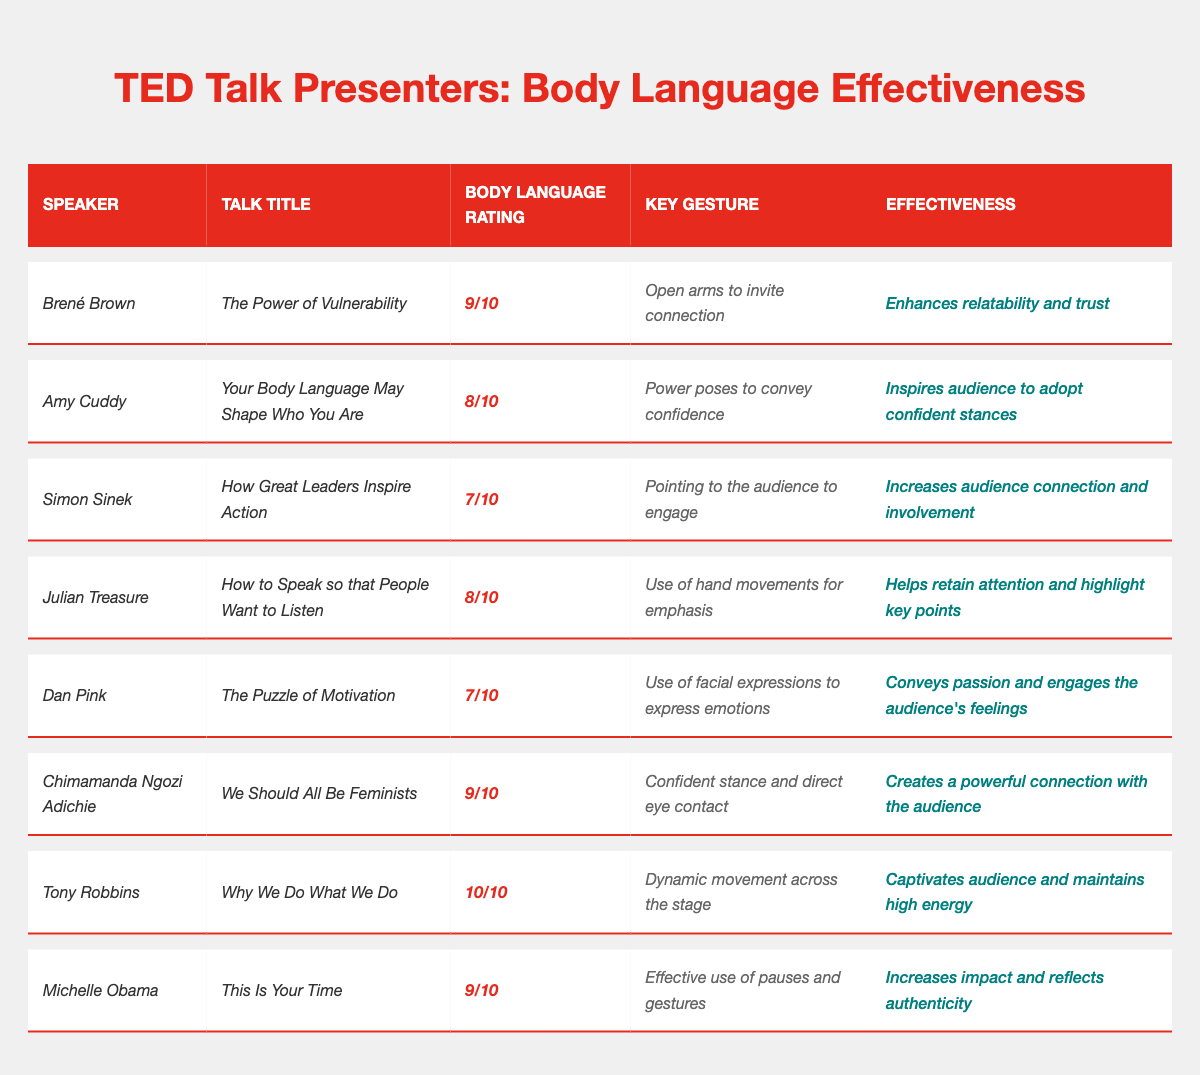What is the body language rating of Tony Robbins? The table shows that Tony Robbins has a body language rating of 10/10.
Answer: 10/10 Which speaker has the lowest body language rating? By checking the table, Simon Sinek and Dan Pink both have the lowest rating of 7/10.
Answer: Simon Sinek and Dan Pink What key gesture does Brené Brown use in her talk? The table indicates that Brené Brown's key gesture is "Open arms to invite connection."
Answer: Open arms to invite connection True or False: Michelle Obama has a higher body language rating than Simon Sinek. Comparing the ratings in the table, Michelle Obama (9/10) has a higher rating than Simon Sinek (7/10), so the statement is true.
Answer: True What is the effectiveness of Amy Cuddy's body language? The effectiveness of Amy Cuddy's body language, as noted in the table, is "Inspires audience to adopt confident stances."
Answer: Inspires audience to adopt confident stances Calculate the average body language rating of all presenters mentioned. The ratings are 9, 8, 7, 8, 7, 9, 10, and 9. Adding them gives 67. There are 8 ratings, so the average is 67/8 = 8.375.
Answer: 8.375 Which speaker uses a confident stance and direct eye contact as a key gesture? The table specifies that Chimamanda Ngozi Adichie uses a confident stance and direct eye contact.
Answer: Chimamanda Ngozi Adichie Who has the highest effectiveness rating and what is it? Tony Robbins has the highest effectiveness rating, which is "Captivates audience and maintains high energy."
Answer: Tony Robbins; Captivates audience and maintains high energy Is there any speaker who has a body language rating of 8/10? Yes, both Amy Cuddy and Julian Treasure have a body language rating of 8/10.
Answer: Yes What body language gesture is highlighted for Julian Treasure? The table lists Julian Treasure's key gesture as "Use of hand movements for emphasis."
Answer: Use of hand movements for emphasis 